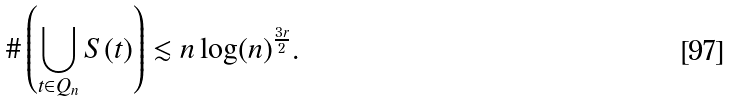Convert formula to latex. <formula><loc_0><loc_0><loc_500><loc_500>\# \left ( \bigcup _ { t \in Q _ { n } } S ( t ) \right ) \lesssim n \log ( n ) ^ { \frac { 3 r } { 2 } } .</formula> 